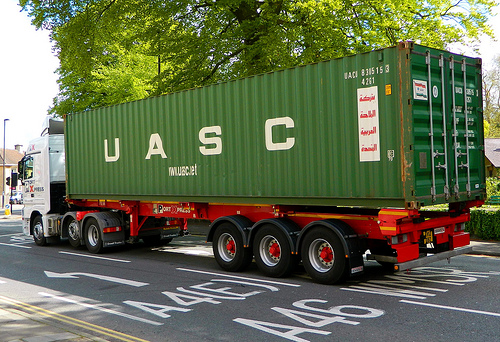Is the container to the left of the house large and brown? No, the container to the left of the house is not large and brown. 